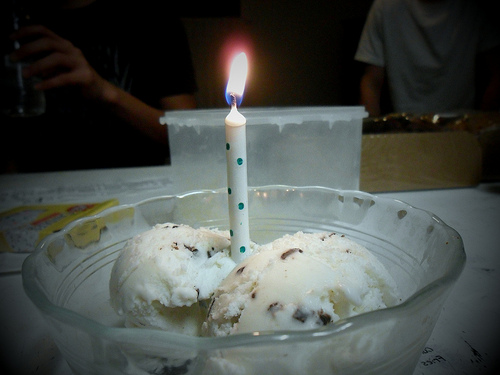<image>
Is the candle in the bowl? Yes. The candle is contained within or inside the bowl, showing a containment relationship. Is there a flame above the ice cream? Yes. The flame is positioned above the ice cream in the vertical space, higher up in the scene. 